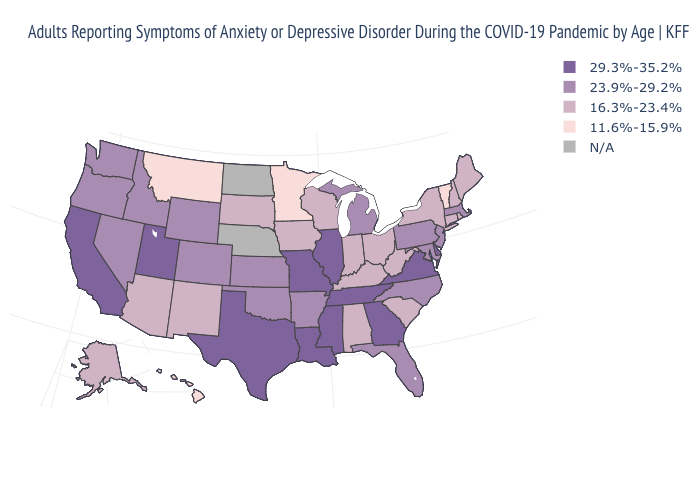Does Minnesota have the lowest value in the USA?
Write a very short answer. Yes. Which states have the highest value in the USA?
Quick response, please. California, Delaware, Georgia, Illinois, Louisiana, Mississippi, Missouri, Tennessee, Texas, Utah, Virginia. Name the states that have a value in the range 29.3%-35.2%?
Concise answer only. California, Delaware, Georgia, Illinois, Louisiana, Mississippi, Missouri, Tennessee, Texas, Utah, Virginia. What is the highest value in the USA?
Keep it brief. 29.3%-35.2%. Is the legend a continuous bar?
Give a very brief answer. No. Does Iowa have the highest value in the MidWest?
Answer briefly. No. Name the states that have a value in the range 29.3%-35.2%?
Short answer required. California, Delaware, Georgia, Illinois, Louisiana, Mississippi, Missouri, Tennessee, Texas, Utah, Virginia. Does New Jersey have the highest value in the Northeast?
Be succinct. Yes. Does Rhode Island have the highest value in the Northeast?
Short answer required. No. Name the states that have a value in the range 29.3%-35.2%?
Write a very short answer. California, Delaware, Georgia, Illinois, Louisiana, Mississippi, Missouri, Tennessee, Texas, Utah, Virginia. Among the states that border Idaho , does Montana have the lowest value?
Keep it brief. Yes. Is the legend a continuous bar?
Quick response, please. No. 